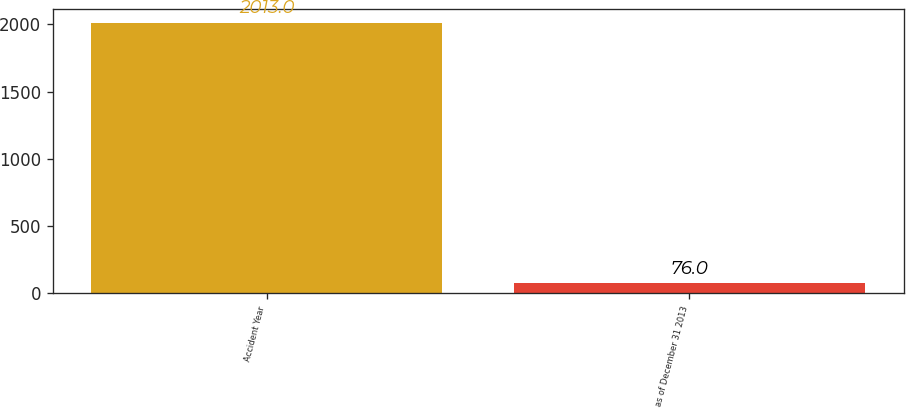Convert chart to OTSL. <chart><loc_0><loc_0><loc_500><loc_500><bar_chart><fcel>Accident Year<fcel>as of December 31 2013<nl><fcel>2013<fcel>76<nl></chart> 